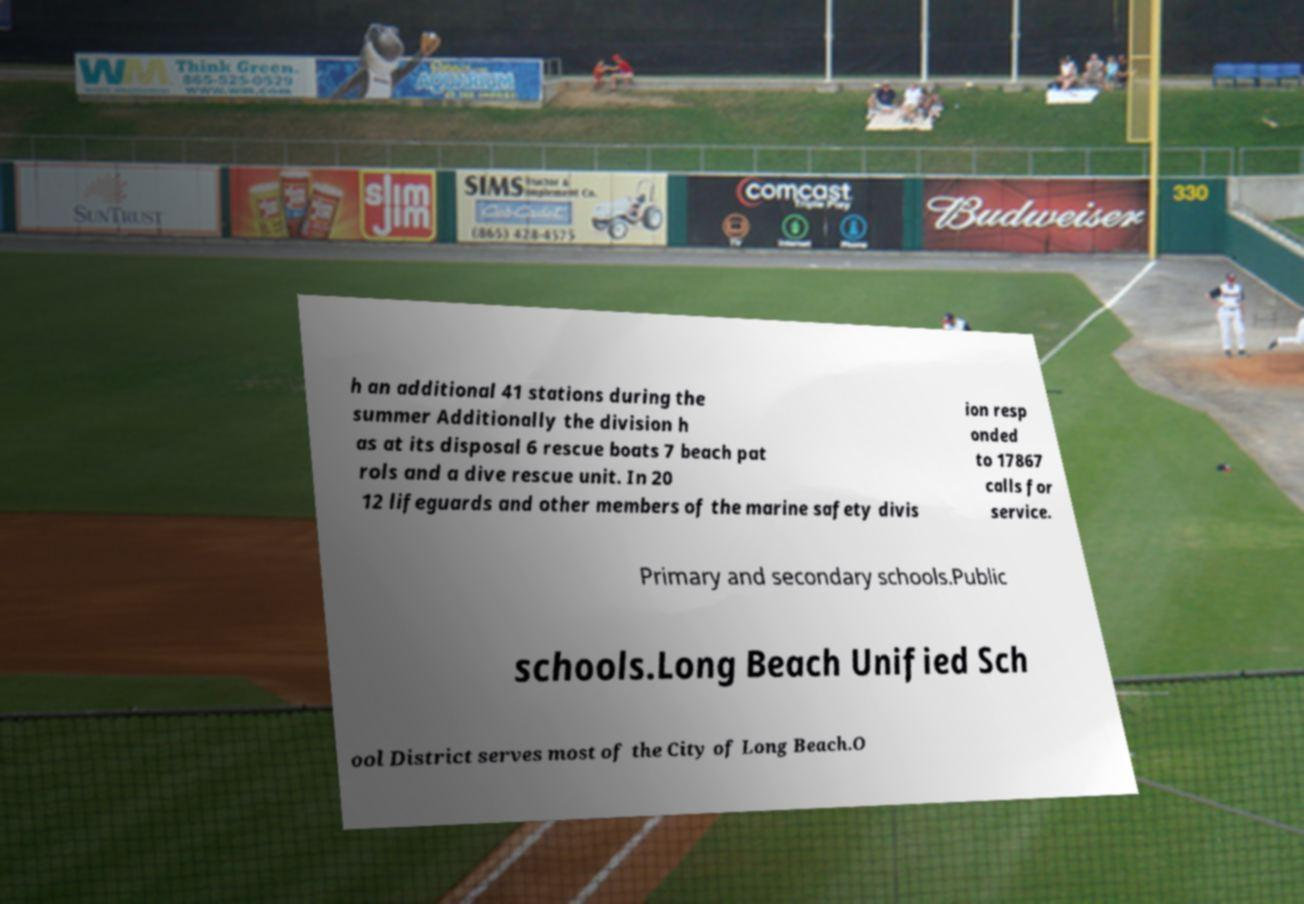Can you read and provide the text displayed in the image?This photo seems to have some interesting text. Can you extract and type it out for me? h an additional 41 stations during the summer Additionally the division h as at its disposal 6 rescue boats 7 beach pat rols and a dive rescue unit. In 20 12 lifeguards and other members of the marine safety divis ion resp onded to 17867 calls for service. Primary and secondary schools.Public schools.Long Beach Unified Sch ool District serves most of the City of Long Beach.O 